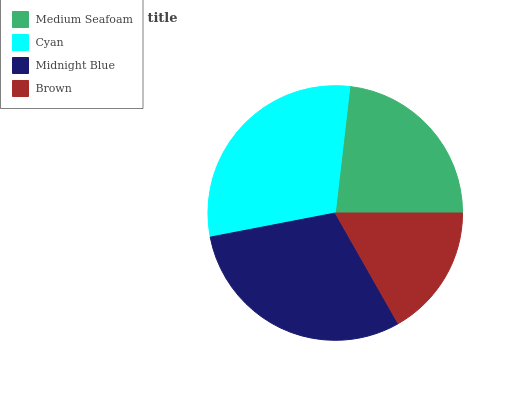Is Brown the minimum?
Answer yes or no. Yes. Is Midnight Blue the maximum?
Answer yes or no. Yes. Is Cyan the minimum?
Answer yes or no. No. Is Cyan the maximum?
Answer yes or no. No. Is Cyan greater than Medium Seafoam?
Answer yes or no. Yes. Is Medium Seafoam less than Cyan?
Answer yes or no. Yes. Is Medium Seafoam greater than Cyan?
Answer yes or no. No. Is Cyan less than Medium Seafoam?
Answer yes or no. No. Is Cyan the high median?
Answer yes or no. Yes. Is Medium Seafoam the low median?
Answer yes or no. Yes. Is Midnight Blue the high median?
Answer yes or no. No. Is Cyan the low median?
Answer yes or no. No. 